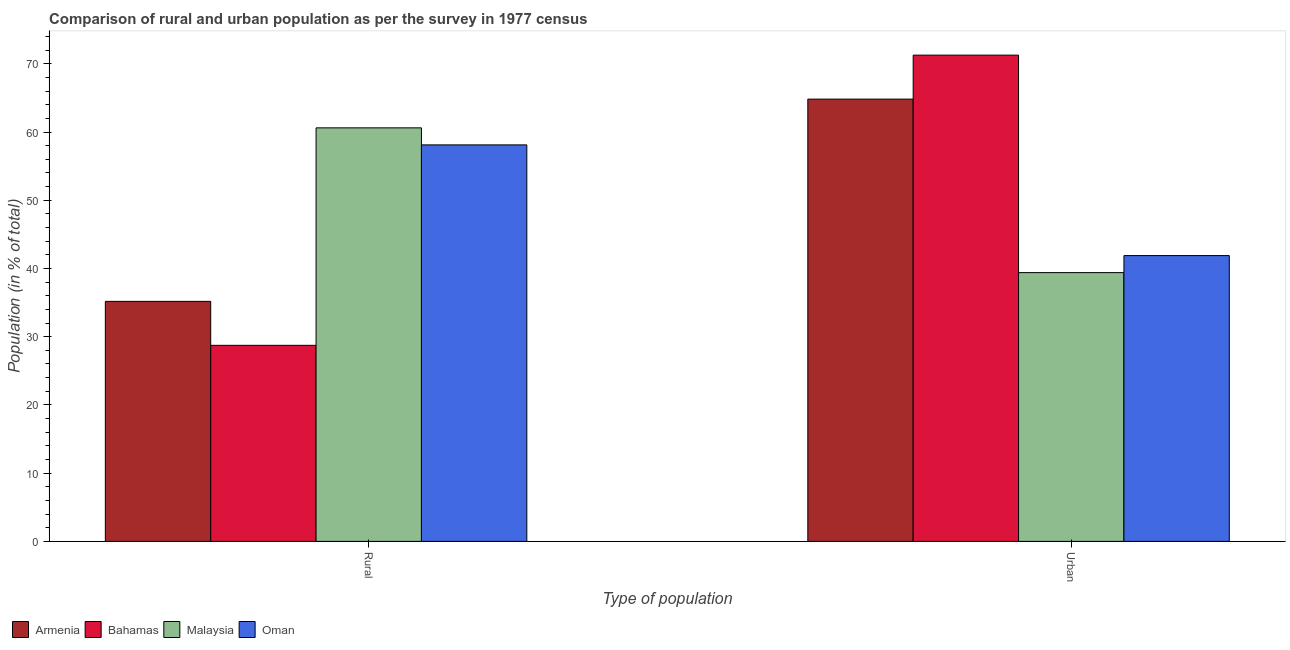How many different coloured bars are there?
Keep it short and to the point. 4. How many groups of bars are there?
Your response must be concise. 2. Are the number of bars per tick equal to the number of legend labels?
Your response must be concise. Yes. How many bars are there on the 2nd tick from the left?
Make the answer very short. 4. What is the label of the 2nd group of bars from the left?
Offer a very short reply. Urban. What is the urban population in Armenia?
Provide a short and direct response. 64.82. Across all countries, what is the maximum urban population?
Provide a short and direct response. 71.27. Across all countries, what is the minimum urban population?
Ensure brevity in your answer.  39.39. In which country was the urban population maximum?
Your answer should be very brief. Bahamas. In which country was the rural population minimum?
Your answer should be very brief. Bahamas. What is the total urban population in the graph?
Provide a short and direct response. 217.37. What is the difference between the urban population in Oman and that in Armenia?
Provide a short and direct response. -22.93. What is the difference between the rural population in Bahamas and the urban population in Armenia?
Your answer should be compact. -36.09. What is the average rural population per country?
Your answer should be very brief. 45.66. What is the difference between the urban population and rural population in Armenia?
Provide a succinct answer. 29.64. What is the ratio of the urban population in Armenia to that in Oman?
Keep it short and to the point. 1.55. Is the urban population in Armenia less than that in Oman?
Your answer should be very brief. No. In how many countries, is the rural population greater than the average rural population taken over all countries?
Offer a very short reply. 2. What does the 4th bar from the left in Urban represents?
Make the answer very short. Oman. What does the 1st bar from the right in Urban represents?
Your answer should be very brief. Oman. How many bars are there?
Provide a short and direct response. 8. Are all the bars in the graph horizontal?
Your answer should be very brief. No. What is the difference between two consecutive major ticks on the Y-axis?
Offer a terse response. 10. Does the graph contain any zero values?
Keep it short and to the point. No. Does the graph contain grids?
Your response must be concise. No. Where does the legend appear in the graph?
Give a very brief answer. Bottom left. How many legend labels are there?
Your answer should be compact. 4. What is the title of the graph?
Give a very brief answer. Comparison of rural and urban population as per the survey in 1977 census. What is the label or title of the X-axis?
Your response must be concise. Type of population. What is the label or title of the Y-axis?
Provide a short and direct response. Population (in % of total). What is the Population (in % of total) in Armenia in Rural?
Your response must be concise. 35.18. What is the Population (in % of total) of Bahamas in Rural?
Make the answer very short. 28.73. What is the Population (in % of total) of Malaysia in Rural?
Your answer should be compact. 60.61. What is the Population (in % of total) of Oman in Rural?
Provide a succinct answer. 58.11. What is the Population (in % of total) in Armenia in Urban?
Give a very brief answer. 64.82. What is the Population (in % of total) in Bahamas in Urban?
Keep it short and to the point. 71.27. What is the Population (in % of total) in Malaysia in Urban?
Provide a short and direct response. 39.39. What is the Population (in % of total) of Oman in Urban?
Ensure brevity in your answer.  41.89. Across all Type of population, what is the maximum Population (in % of total) of Armenia?
Ensure brevity in your answer.  64.82. Across all Type of population, what is the maximum Population (in % of total) in Bahamas?
Provide a succinct answer. 71.27. Across all Type of population, what is the maximum Population (in % of total) in Malaysia?
Your response must be concise. 60.61. Across all Type of population, what is the maximum Population (in % of total) in Oman?
Provide a short and direct response. 58.11. Across all Type of population, what is the minimum Population (in % of total) of Armenia?
Offer a very short reply. 35.18. Across all Type of population, what is the minimum Population (in % of total) of Bahamas?
Your response must be concise. 28.73. Across all Type of population, what is the minimum Population (in % of total) of Malaysia?
Ensure brevity in your answer.  39.39. Across all Type of population, what is the minimum Population (in % of total) in Oman?
Provide a succinct answer. 41.89. What is the total Population (in % of total) in Armenia in the graph?
Your answer should be compact. 100. What is the total Population (in % of total) of Oman in the graph?
Make the answer very short. 100. What is the difference between the Population (in % of total) in Armenia in Rural and that in Urban?
Offer a very short reply. -29.64. What is the difference between the Population (in % of total) in Bahamas in Rural and that in Urban?
Offer a very short reply. -42.53. What is the difference between the Population (in % of total) in Malaysia in Rural and that in Urban?
Make the answer very short. 21.22. What is the difference between the Population (in % of total) of Oman in Rural and that in Urban?
Your answer should be very brief. 16.22. What is the difference between the Population (in % of total) in Armenia in Rural and the Population (in % of total) in Bahamas in Urban?
Provide a succinct answer. -36.09. What is the difference between the Population (in % of total) of Armenia in Rural and the Population (in % of total) of Malaysia in Urban?
Your answer should be very brief. -4.21. What is the difference between the Population (in % of total) in Armenia in Rural and the Population (in % of total) in Oman in Urban?
Give a very brief answer. -6.71. What is the difference between the Population (in % of total) in Bahamas in Rural and the Population (in % of total) in Malaysia in Urban?
Your response must be concise. -10.66. What is the difference between the Population (in % of total) of Bahamas in Rural and the Population (in % of total) of Oman in Urban?
Give a very brief answer. -13.15. What is the difference between the Population (in % of total) of Malaysia in Rural and the Population (in % of total) of Oman in Urban?
Offer a very short reply. 18.72. What is the average Population (in % of total) in Malaysia per Type of population?
Your response must be concise. 50. What is the average Population (in % of total) of Oman per Type of population?
Give a very brief answer. 50. What is the difference between the Population (in % of total) of Armenia and Population (in % of total) of Bahamas in Rural?
Your response must be concise. 6.45. What is the difference between the Population (in % of total) in Armenia and Population (in % of total) in Malaysia in Rural?
Your answer should be very brief. -25.43. What is the difference between the Population (in % of total) of Armenia and Population (in % of total) of Oman in Rural?
Keep it short and to the point. -22.93. What is the difference between the Population (in % of total) of Bahamas and Population (in % of total) of Malaysia in Rural?
Provide a short and direct response. -31.88. What is the difference between the Population (in % of total) in Bahamas and Population (in % of total) in Oman in Rural?
Offer a terse response. -29.38. What is the difference between the Population (in % of total) of Malaysia and Population (in % of total) of Oman in Rural?
Offer a very short reply. 2.5. What is the difference between the Population (in % of total) of Armenia and Population (in % of total) of Bahamas in Urban?
Your response must be concise. -6.45. What is the difference between the Population (in % of total) in Armenia and Population (in % of total) in Malaysia in Urban?
Your response must be concise. 25.43. What is the difference between the Population (in % of total) in Armenia and Population (in % of total) in Oman in Urban?
Your response must be concise. 22.93. What is the difference between the Population (in % of total) in Bahamas and Population (in % of total) in Malaysia in Urban?
Provide a succinct answer. 31.88. What is the difference between the Population (in % of total) in Bahamas and Population (in % of total) in Oman in Urban?
Your response must be concise. 29.38. What is the difference between the Population (in % of total) of Malaysia and Population (in % of total) of Oman in Urban?
Provide a succinct answer. -2.5. What is the ratio of the Population (in % of total) of Armenia in Rural to that in Urban?
Make the answer very short. 0.54. What is the ratio of the Population (in % of total) in Bahamas in Rural to that in Urban?
Your answer should be very brief. 0.4. What is the ratio of the Population (in % of total) in Malaysia in Rural to that in Urban?
Give a very brief answer. 1.54. What is the ratio of the Population (in % of total) in Oman in Rural to that in Urban?
Your answer should be compact. 1.39. What is the difference between the highest and the second highest Population (in % of total) of Armenia?
Ensure brevity in your answer.  29.64. What is the difference between the highest and the second highest Population (in % of total) in Bahamas?
Ensure brevity in your answer.  42.53. What is the difference between the highest and the second highest Population (in % of total) in Malaysia?
Your answer should be very brief. 21.22. What is the difference between the highest and the second highest Population (in % of total) of Oman?
Provide a succinct answer. 16.22. What is the difference between the highest and the lowest Population (in % of total) in Armenia?
Make the answer very short. 29.64. What is the difference between the highest and the lowest Population (in % of total) in Bahamas?
Your response must be concise. 42.53. What is the difference between the highest and the lowest Population (in % of total) of Malaysia?
Your answer should be compact. 21.22. What is the difference between the highest and the lowest Population (in % of total) in Oman?
Keep it short and to the point. 16.22. 